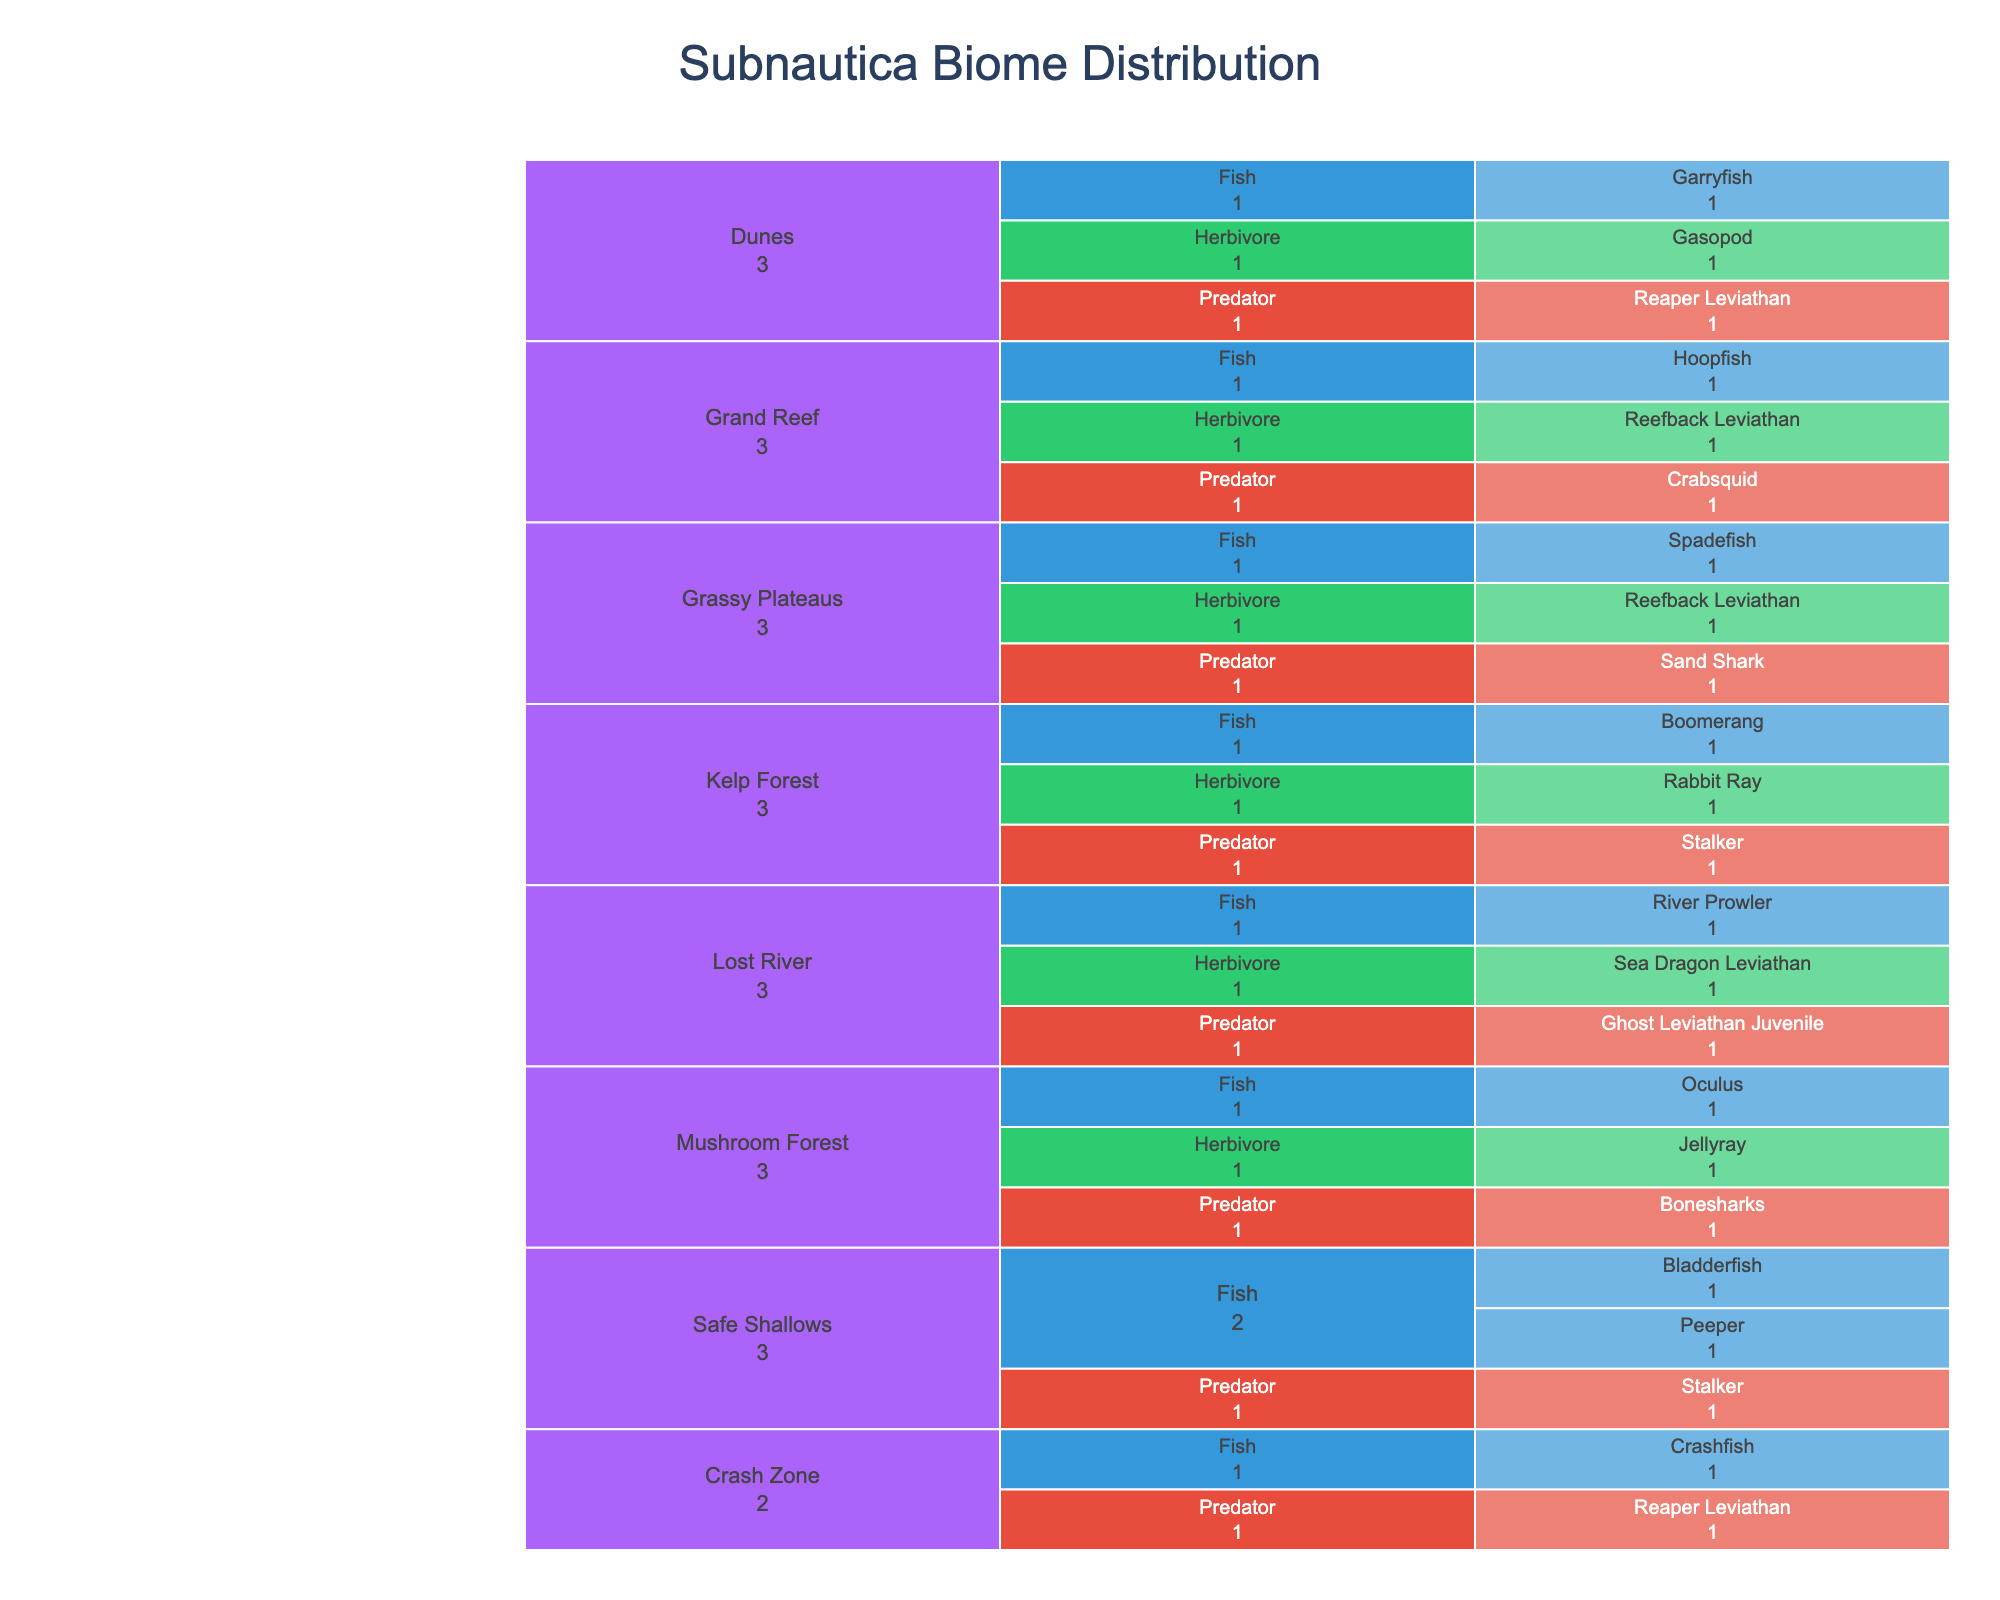Which biome has the most predator species? To answer this question, we need to look at each biome and count the predator species within that biome on the icicle chart. The biome with the largest count of predator species is the one we are looking for.
Answer: Lost River How many different herbivore species are found in the Dunes? The icicle chart shows a breakdown by biome, then by creature type, finally by species. We look for the Dunes biome, then check the number of herbivore species listed.
Answer: 1 Compare the number of fish species in the Grassy Plateaus with those in the Safe Shallows. Which biome has more? First, count the fish species under the Grassy Plateaus and Safe Shallows in the icicle chart. Compare these counts to determine which is higher.
Answer: Safe Shallows What's the total number of distinct species present in the Kelp Forest? For the Kelp Forest, count the different species listed under each creature type (Fish, Predator, Herbivore) in the icicle chart and sum them up.
Answer: 3 Is the number of species in the Grand Reef greater than in the Mushroom Forest? Count the total species in both Grand Reef and Mushroom Forest, comparing the two sums to find out if Grand Reef has more.
Answer: No Which creature type has the highest number of unique species listed in the icicle chart? Summarize the count of unique species under each creature type (Fish, Predator, Herbivore) across all biomes and identify the creature type with the highest count.
Answer: Fish How many species are listed under biomes containing Leviathan creatures? Check biomes with Leviathan creatures (Grassy Plateaus, Dunes, Lost River, Grand Reef), then count all species listed in these biomes and sum them up.
Answer: 9 